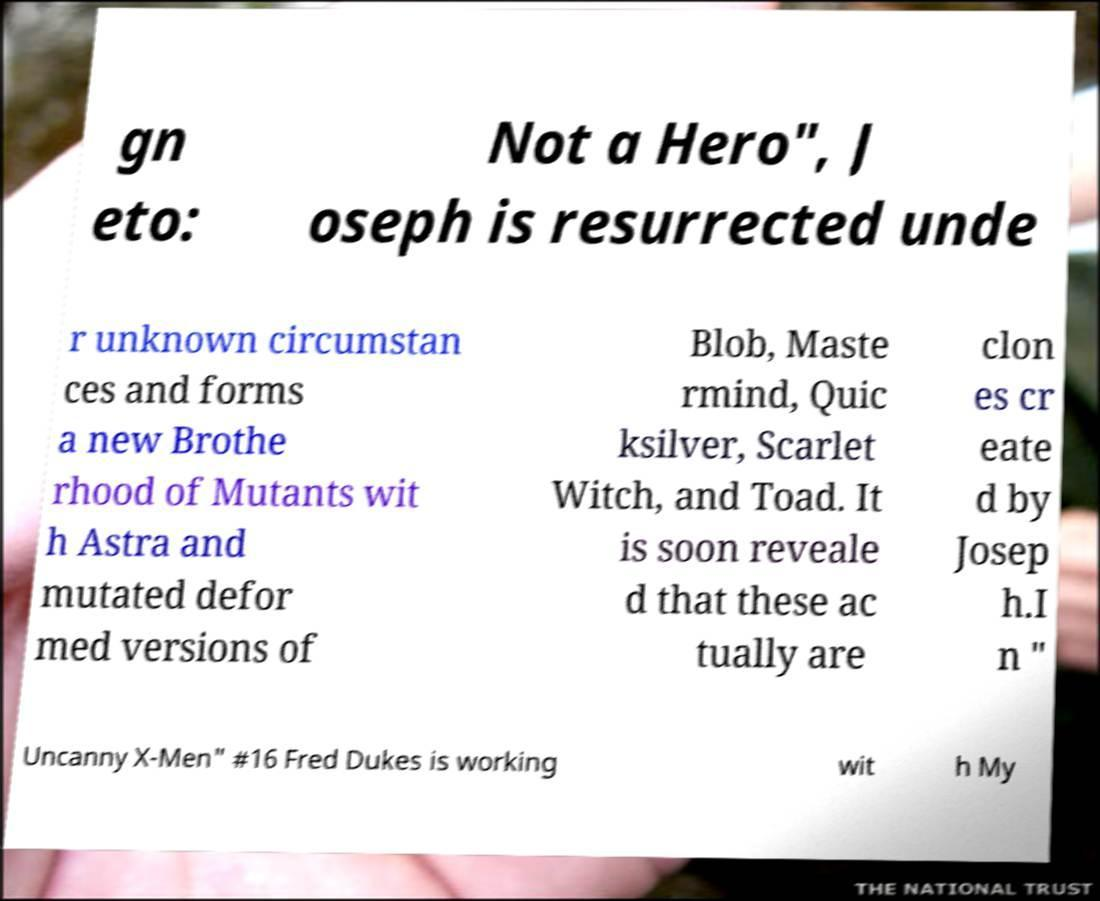What kind of document does this text appear to be from? The text appears to be from a page discussing plot elements related to the X-Men series, possibly from a comic book, a novel, or a magazine article analyzing the series' characters and story arcs. 